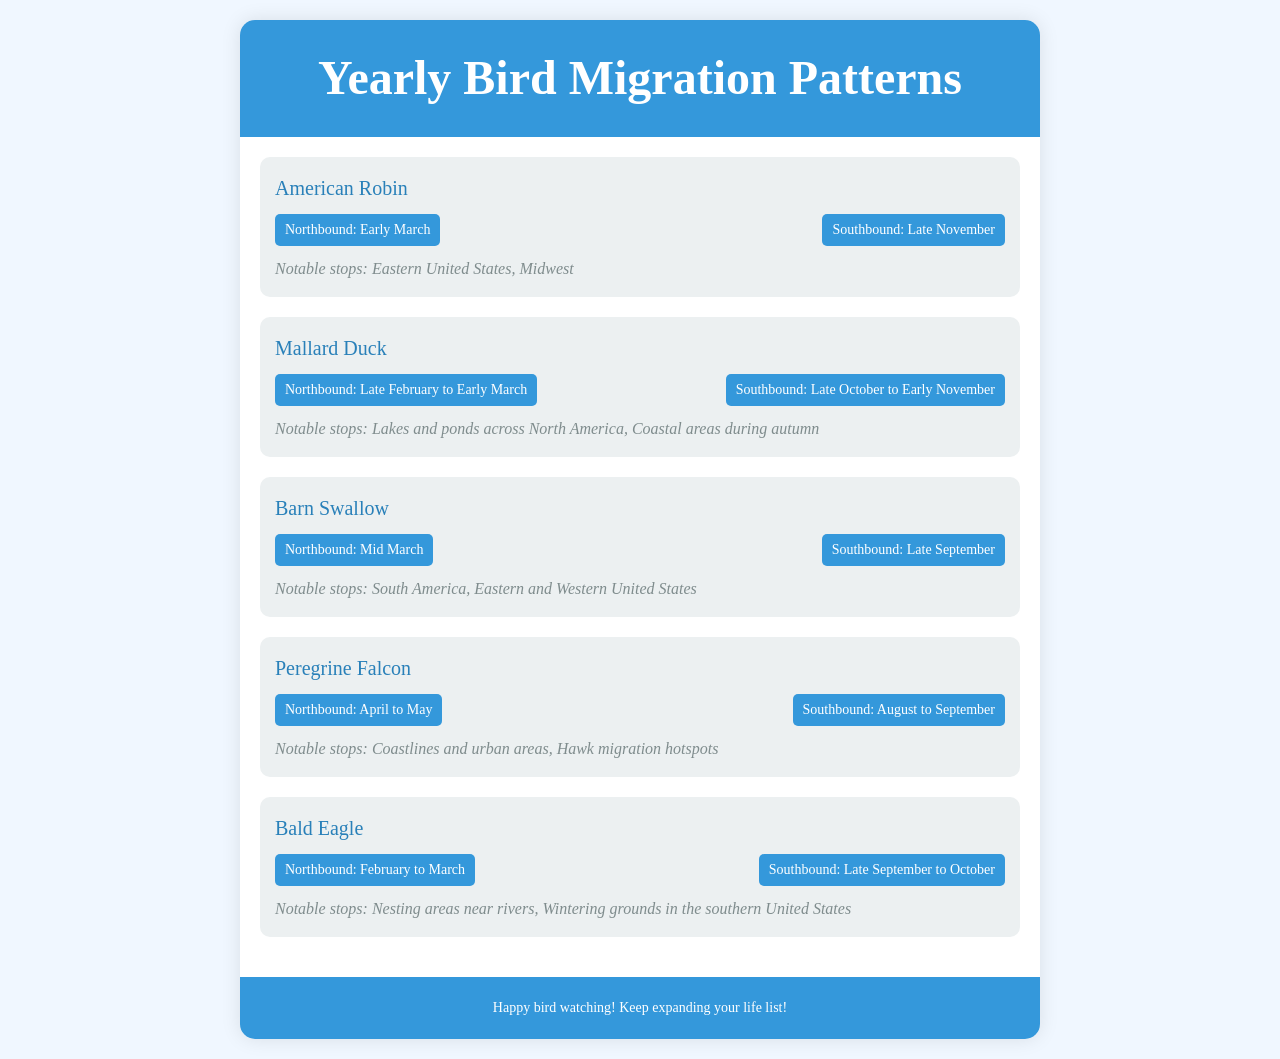What is the migration period for the American Robin northbound? The document states that the American Robin's northbound migration period is "Early March."
Answer: Early March When does the Barn Swallow migrate southbound? According to the document, the Barn Swallow migrates southbound in "Late September."
Answer: Late September What notable stops are mentioned for the Peregrine Falcon? The document lists "Coastlines and urban areas, Hawk migration hotspots" as notable stops for the Peregrine Falcon.
Answer: Coastlines and urban areas, Hawk migration hotspots Which bird species migrates northbound between April and May? The document indicates that the "Peregrine Falcon" migrates northbound during this period.
Answer: Peregrine Falcon What is the southbound migration period for the Bald Eagle? The document states the Bald Eagle's southbound migration period is "Late September to October."
Answer: Late September to October How many species are listed in the document? The document includes five bird species.
Answer: Five species What is the earliest northbound migration date mentioned for any species? The earliest northbound migration date mentioned in the document is for the "Mallard Duck" starting in "Late February."
Answer: Late February Which species migrates southbound in late October? The document notes that the "Mallard Duck" migrates southbound in late October.
Answer: Mallard Duck What notable stops are listed for the American Robin? The document indicates the notable stops for the American Robin are "Eastern United States, Midwest."
Answer: Eastern United States, Midwest 